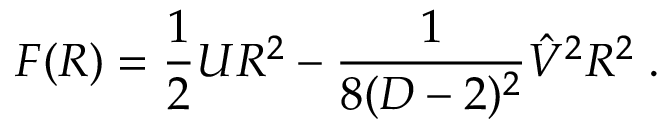Convert formula to latex. <formula><loc_0><loc_0><loc_500><loc_500>F ( R ) = { \frac { 1 } { 2 } } U R ^ { 2 } - { \frac { 1 } { 8 ( D - 2 ) ^ { 2 } } } \hat { V } ^ { 2 } R ^ { 2 } \, .</formula> 